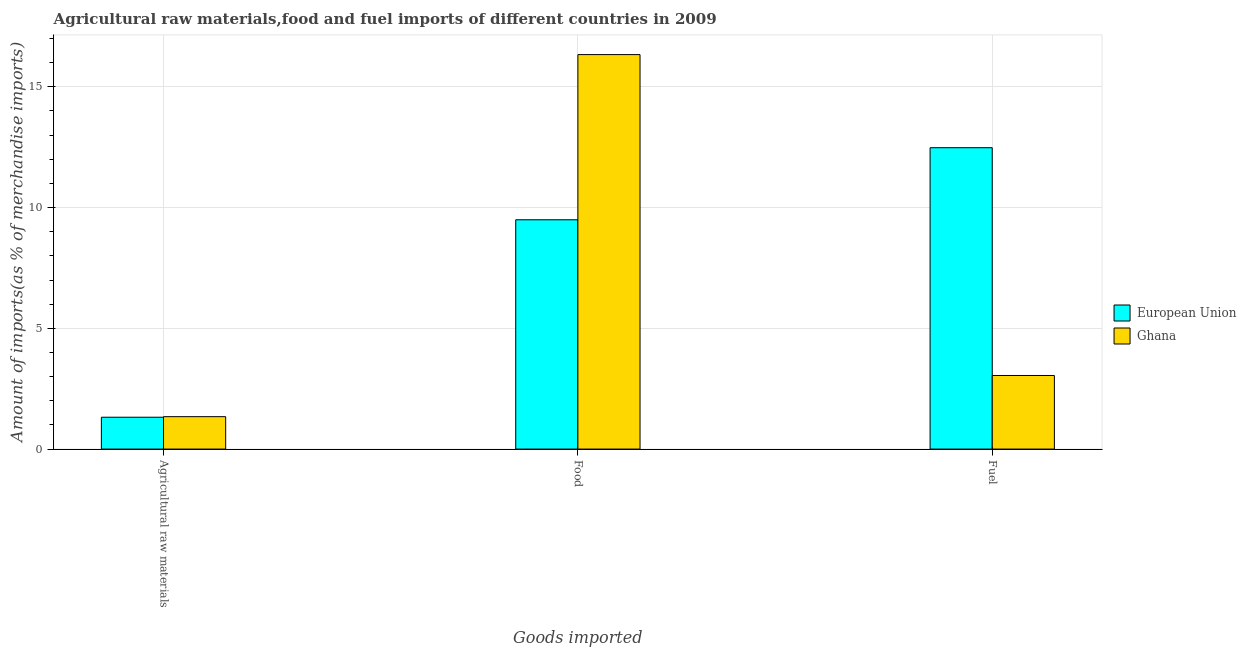How many different coloured bars are there?
Ensure brevity in your answer.  2. How many groups of bars are there?
Ensure brevity in your answer.  3. Are the number of bars per tick equal to the number of legend labels?
Your response must be concise. Yes. How many bars are there on the 2nd tick from the right?
Give a very brief answer. 2. What is the label of the 2nd group of bars from the left?
Provide a succinct answer. Food. What is the percentage of food imports in European Union?
Give a very brief answer. 9.5. Across all countries, what is the maximum percentage of fuel imports?
Provide a short and direct response. 12.48. Across all countries, what is the minimum percentage of food imports?
Your answer should be very brief. 9.5. In which country was the percentage of raw materials imports minimum?
Provide a succinct answer. European Union. What is the total percentage of fuel imports in the graph?
Give a very brief answer. 15.53. What is the difference between the percentage of food imports in European Union and that in Ghana?
Provide a succinct answer. -6.84. What is the difference between the percentage of raw materials imports in Ghana and the percentage of food imports in European Union?
Provide a short and direct response. -8.15. What is the average percentage of raw materials imports per country?
Provide a succinct answer. 1.33. What is the difference between the percentage of fuel imports and percentage of raw materials imports in Ghana?
Ensure brevity in your answer.  1.7. What is the ratio of the percentage of fuel imports in European Union to that in Ghana?
Your answer should be compact. 4.1. Is the percentage of food imports in Ghana less than that in European Union?
Your answer should be compact. No. Is the difference between the percentage of fuel imports in Ghana and European Union greater than the difference between the percentage of food imports in Ghana and European Union?
Offer a very short reply. No. What is the difference between the highest and the second highest percentage of food imports?
Provide a succinct answer. 6.84. What is the difference between the highest and the lowest percentage of raw materials imports?
Your response must be concise. 0.02. Is the sum of the percentage of raw materials imports in European Union and Ghana greater than the maximum percentage of fuel imports across all countries?
Offer a terse response. No. What does the 1st bar from the left in Food represents?
Your answer should be compact. European Union. Is it the case that in every country, the sum of the percentage of raw materials imports and percentage of food imports is greater than the percentage of fuel imports?
Offer a terse response. No. What is the difference between two consecutive major ticks on the Y-axis?
Your answer should be very brief. 5. Does the graph contain any zero values?
Your answer should be very brief. No. Does the graph contain grids?
Your response must be concise. Yes. How many legend labels are there?
Offer a very short reply. 2. What is the title of the graph?
Give a very brief answer. Agricultural raw materials,food and fuel imports of different countries in 2009. Does "Somalia" appear as one of the legend labels in the graph?
Ensure brevity in your answer.  No. What is the label or title of the X-axis?
Your answer should be very brief. Goods imported. What is the label or title of the Y-axis?
Give a very brief answer. Amount of imports(as % of merchandise imports). What is the Amount of imports(as % of merchandise imports) of European Union in Agricultural raw materials?
Make the answer very short. 1.32. What is the Amount of imports(as % of merchandise imports) of Ghana in Agricultural raw materials?
Keep it short and to the point. 1.34. What is the Amount of imports(as % of merchandise imports) of European Union in Food?
Offer a terse response. 9.5. What is the Amount of imports(as % of merchandise imports) in Ghana in Food?
Offer a very short reply. 16.33. What is the Amount of imports(as % of merchandise imports) of European Union in Fuel?
Provide a succinct answer. 12.48. What is the Amount of imports(as % of merchandise imports) of Ghana in Fuel?
Ensure brevity in your answer.  3.05. Across all Goods imported, what is the maximum Amount of imports(as % of merchandise imports) of European Union?
Give a very brief answer. 12.48. Across all Goods imported, what is the maximum Amount of imports(as % of merchandise imports) in Ghana?
Provide a short and direct response. 16.33. Across all Goods imported, what is the minimum Amount of imports(as % of merchandise imports) in European Union?
Provide a short and direct response. 1.32. Across all Goods imported, what is the minimum Amount of imports(as % of merchandise imports) of Ghana?
Your response must be concise. 1.34. What is the total Amount of imports(as % of merchandise imports) in European Union in the graph?
Provide a succinct answer. 23.29. What is the total Amount of imports(as % of merchandise imports) in Ghana in the graph?
Your response must be concise. 20.72. What is the difference between the Amount of imports(as % of merchandise imports) of European Union in Agricultural raw materials and that in Food?
Provide a short and direct response. -8.18. What is the difference between the Amount of imports(as % of merchandise imports) in Ghana in Agricultural raw materials and that in Food?
Give a very brief answer. -14.99. What is the difference between the Amount of imports(as % of merchandise imports) of European Union in Agricultural raw materials and that in Fuel?
Your answer should be very brief. -11.16. What is the difference between the Amount of imports(as % of merchandise imports) of Ghana in Agricultural raw materials and that in Fuel?
Your answer should be very brief. -1.7. What is the difference between the Amount of imports(as % of merchandise imports) in European Union in Food and that in Fuel?
Make the answer very short. -2.98. What is the difference between the Amount of imports(as % of merchandise imports) of Ghana in Food and that in Fuel?
Provide a short and direct response. 13.29. What is the difference between the Amount of imports(as % of merchandise imports) in European Union in Agricultural raw materials and the Amount of imports(as % of merchandise imports) in Ghana in Food?
Your response must be concise. -15.02. What is the difference between the Amount of imports(as % of merchandise imports) in European Union in Agricultural raw materials and the Amount of imports(as % of merchandise imports) in Ghana in Fuel?
Your answer should be very brief. -1.73. What is the difference between the Amount of imports(as % of merchandise imports) of European Union in Food and the Amount of imports(as % of merchandise imports) of Ghana in Fuel?
Ensure brevity in your answer.  6.45. What is the average Amount of imports(as % of merchandise imports) of European Union per Goods imported?
Give a very brief answer. 7.76. What is the average Amount of imports(as % of merchandise imports) in Ghana per Goods imported?
Ensure brevity in your answer.  6.91. What is the difference between the Amount of imports(as % of merchandise imports) of European Union and Amount of imports(as % of merchandise imports) of Ghana in Agricultural raw materials?
Provide a short and direct response. -0.02. What is the difference between the Amount of imports(as % of merchandise imports) of European Union and Amount of imports(as % of merchandise imports) of Ghana in Food?
Provide a succinct answer. -6.84. What is the difference between the Amount of imports(as % of merchandise imports) in European Union and Amount of imports(as % of merchandise imports) in Ghana in Fuel?
Keep it short and to the point. 9.43. What is the ratio of the Amount of imports(as % of merchandise imports) in European Union in Agricultural raw materials to that in Food?
Your answer should be very brief. 0.14. What is the ratio of the Amount of imports(as % of merchandise imports) of Ghana in Agricultural raw materials to that in Food?
Give a very brief answer. 0.08. What is the ratio of the Amount of imports(as % of merchandise imports) of European Union in Agricultural raw materials to that in Fuel?
Offer a terse response. 0.11. What is the ratio of the Amount of imports(as % of merchandise imports) in Ghana in Agricultural raw materials to that in Fuel?
Provide a short and direct response. 0.44. What is the ratio of the Amount of imports(as % of merchandise imports) in European Union in Food to that in Fuel?
Your answer should be very brief. 0.76. What is the ratio of the Amount of imports(as % of merchandise imports) of Ghana in Food to that in Fuel?
Provide a succinct answer. 5.36. What is the difference between the highest and the second highest Amount of imports(as % of merchandise imports) of European Union?
Provide a succinct answer. 2.98. What is the difference between the highest and the second highest Amount of imports(as % of merchandise imports) of Ghana?
Make the answer very short. 13.29. What is the difference between the highest and the lowest Amount of imports(as % of merchandise imports) in European Union?
Provide a succinct answer. 11.16. What is the difference between the highest and the lowest Amount of imports(as % of merchandise imports) in Ghana?
Make the answer very short. 14.99. 